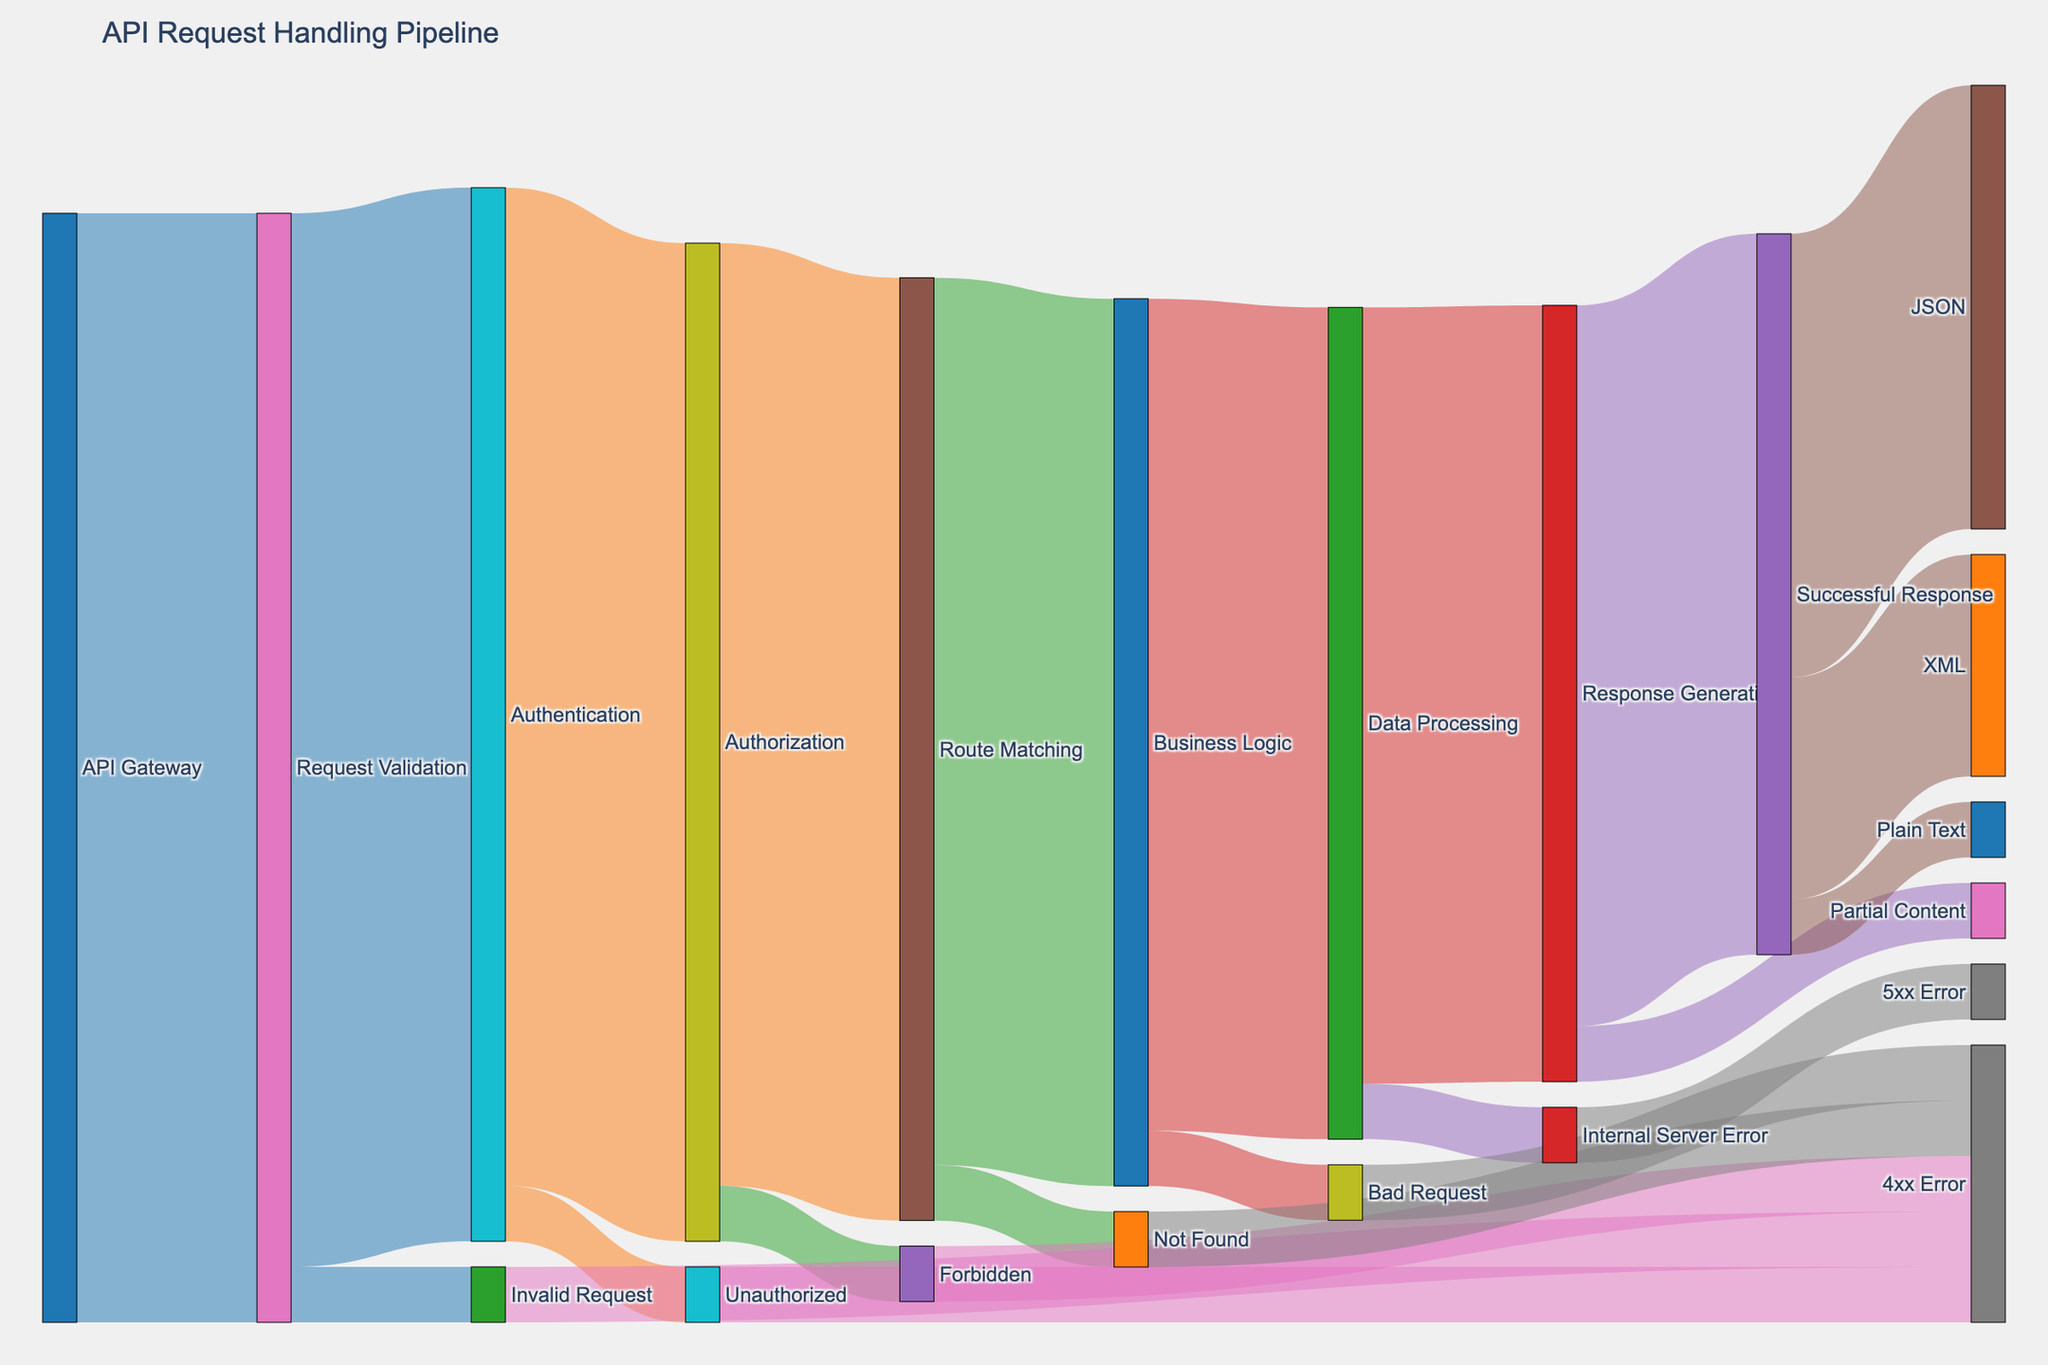what is the total number of requests that reach the 'Business Logic' stage? To calculate the total number of requests reaching 'Business Logic,' add those coming from 'Route Matching.' The values are: 'Route Matching' to 'Business Logic' is 800. So, the total requests reaching 'Business Logic' is 800.
Answer: 800 Which stage has the highest number of requests dropped due to errors? To find the stage with the highest number of dropped requests, look for the target stages representing errors and their corresponding values. Here are the values: 'Invalid Request' from 'Request Validation' is 50, 'Unauthorized' from 'Authentication' is 50, 'Forbidden' from 'Authorization' is 50, 'Not Found' from 'Route Matching' is 50, 'Bad Request' from 'Business Logic' is 50, and 'Internal Server Error' from 'Data Processing' is 50. Since all error stages drop an equal number of requests, each 50, they are equivalent.
Answer: 50 What is the percentage of requests that make it from 'API Gateway' to 'Successful Response'? First, calculate the total number of requests entering 'API Gateway,' which is 1000. Then, determine how many reach 'Successful Response' via 'Response Generation,' which is 650. Finally, calculate the percentage: (650/1000) * 100 = 65%.
Answer: 65% Which final format received the least number of successful responses? To determine this, look at the final outputs from the 'Successful Response' stage. The values are: 'JSON' is 400, 'XML' is 200, and 'Plain Text' is 50. The least number of successful responses is received by 'Plain Text'.
Answer: Plain Text How many requests fail before reaching the 'Response Generation' stage? To calculate the requests failing before reaching 'Response Generation,' sum the values for all error terminates from previous stages: 'Invalid Request' (50), 'Unauthorized' (50), 'Forbidden' (50), 'Not Found' (50), and 'Bad Request' (50). So, 50+50+50+50+50 = 250.
Answer: 250 How many successful responses are generated in total? Successful responses are separated into 'JSON', 'XML', and 'Plain Text.' Add these numbers to find the total successful responses: 400 (JSON) + 200 (XML) + 50 (Plain Text) = 650.
Answer: 650 Compare the number of requests handled by 'Route Matching' and 'Data Processing.' Which stage handles more requests? 'Route Matching' receives 850 requests from 'Authorization' and 'Data Processing' receives 750 requests from 'Business Logic.' Thus, 'Route Matching' handles more requests.
Answer: Route Matching How many requests end up resulting in a 4xx error? Sum all requests ending in a 4xx error: 'Invalid Request' (50), 'Unauthorized' (50), 'Forbidden' (50), 'Not Found' (50), and 'Bad Request' (50). The total is 50+50+50+50+50 = 250.
Answer: 250 What is the ratio of 'Internal Server Error' to '4xx Error' requests? 'Internal Server Error' requests are 50, and '4xx Error' requests total 250. The ratio of 'Internal Server Error' to '4xx Error' is 50:250, which simplifies to 1:5.
Answer: 1:5 What is the proportion of requests dropped due to 'Authentication' failures relative to all requests starting at 'API Gateway'? 'Unauthorized' in 'Authentication' drops 50 requests. Starting at 'API Gateway' there are 1000 requests. The proportion is 50/1000 = 0.05 or 5%.
Answer: 5% 